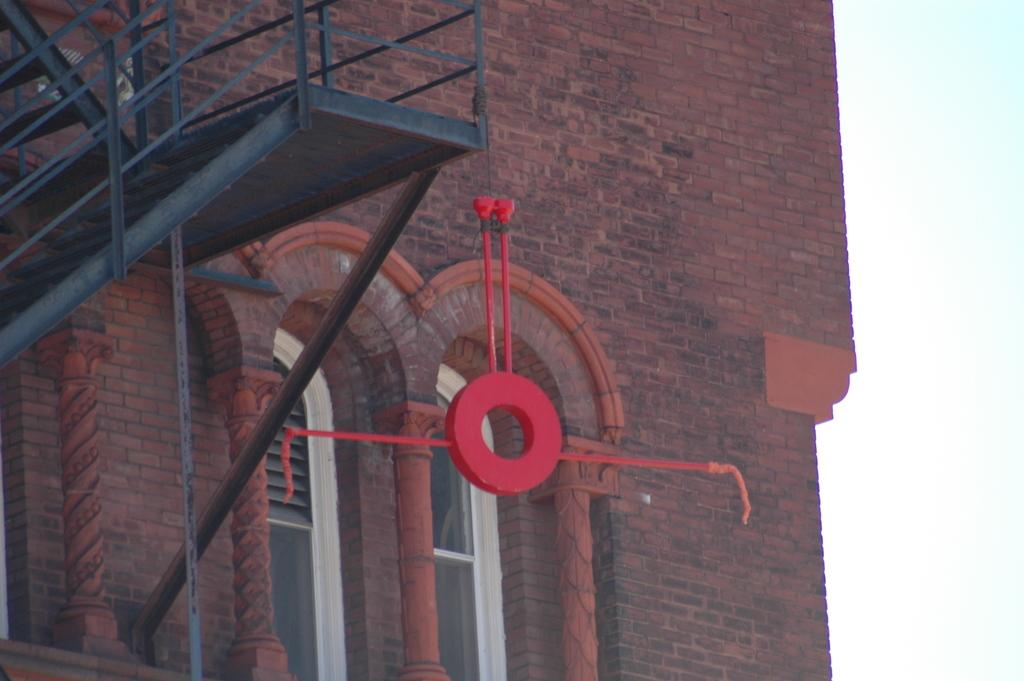What type of structure is present in the image? There is a building in the image. Are there any architectural features visible in the image? Yes, there are stairs in the image. What is attached to the stairs? An object is tied to the stairs. What part of the natural environment can be seen in the image? The sky is visible at the side of the image. How does the pollution affect the building in the image? There is no mention of pollution in the image, so we cannot determine its effect on the building. 